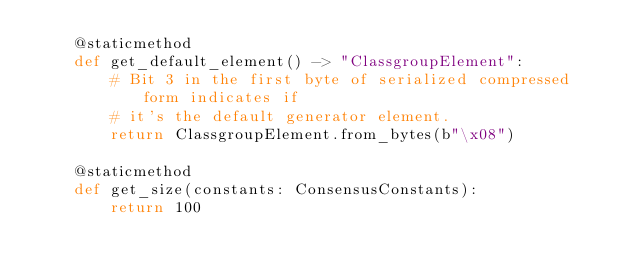Convert code to text. <code><loc_0><loc_0><loc_500><loc_500><_Python_>    @staticmethod
    def get_default_element() -> "ClassgroupElement":
        # Bit 3 in the first byte of serialized compressed form indicates if
        # it's the default generator element.
        return ClassgroupElement.from_bytes(b"\x08")

    @staticmethod
    def get_size(constants: ConsensusConstants):
        return 100
</code> 